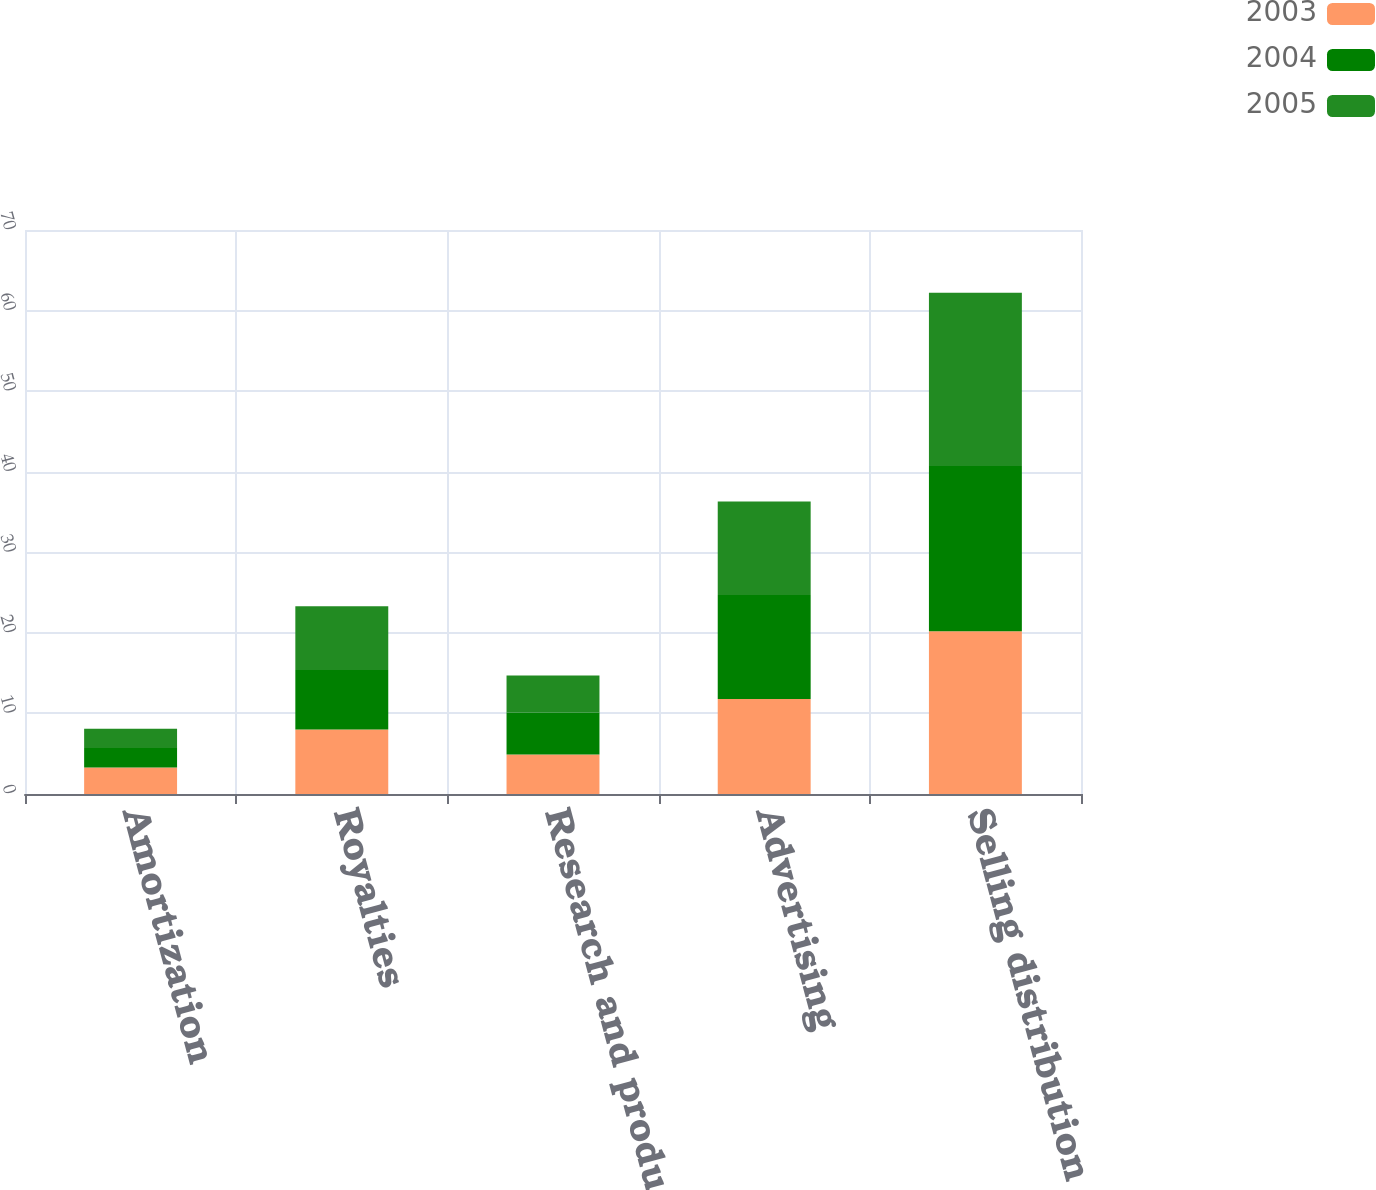<chart> <loc_0><loc_0><loc_500><loc_500><stacked_bar_chart><ecel><fcel>Amortization<fcel>Royalties<fcel>Research and product<fcel>Advertising<fcel>Selling distribution and<nl><fcel>2003<fcel>3.3<fcel>8<fcel>4.9<fcel>11.8<fcel>20.2<nl><fcel>2004<fcel>2.4<fcel>7.4<fcel>5.2<fcel>12.9<fcel>20.5<nl><fcel>2005<fcel>2.4<fcel>7.9<fcel>4.6<fcel>11.6<fcel>21.5<nl></chart> 